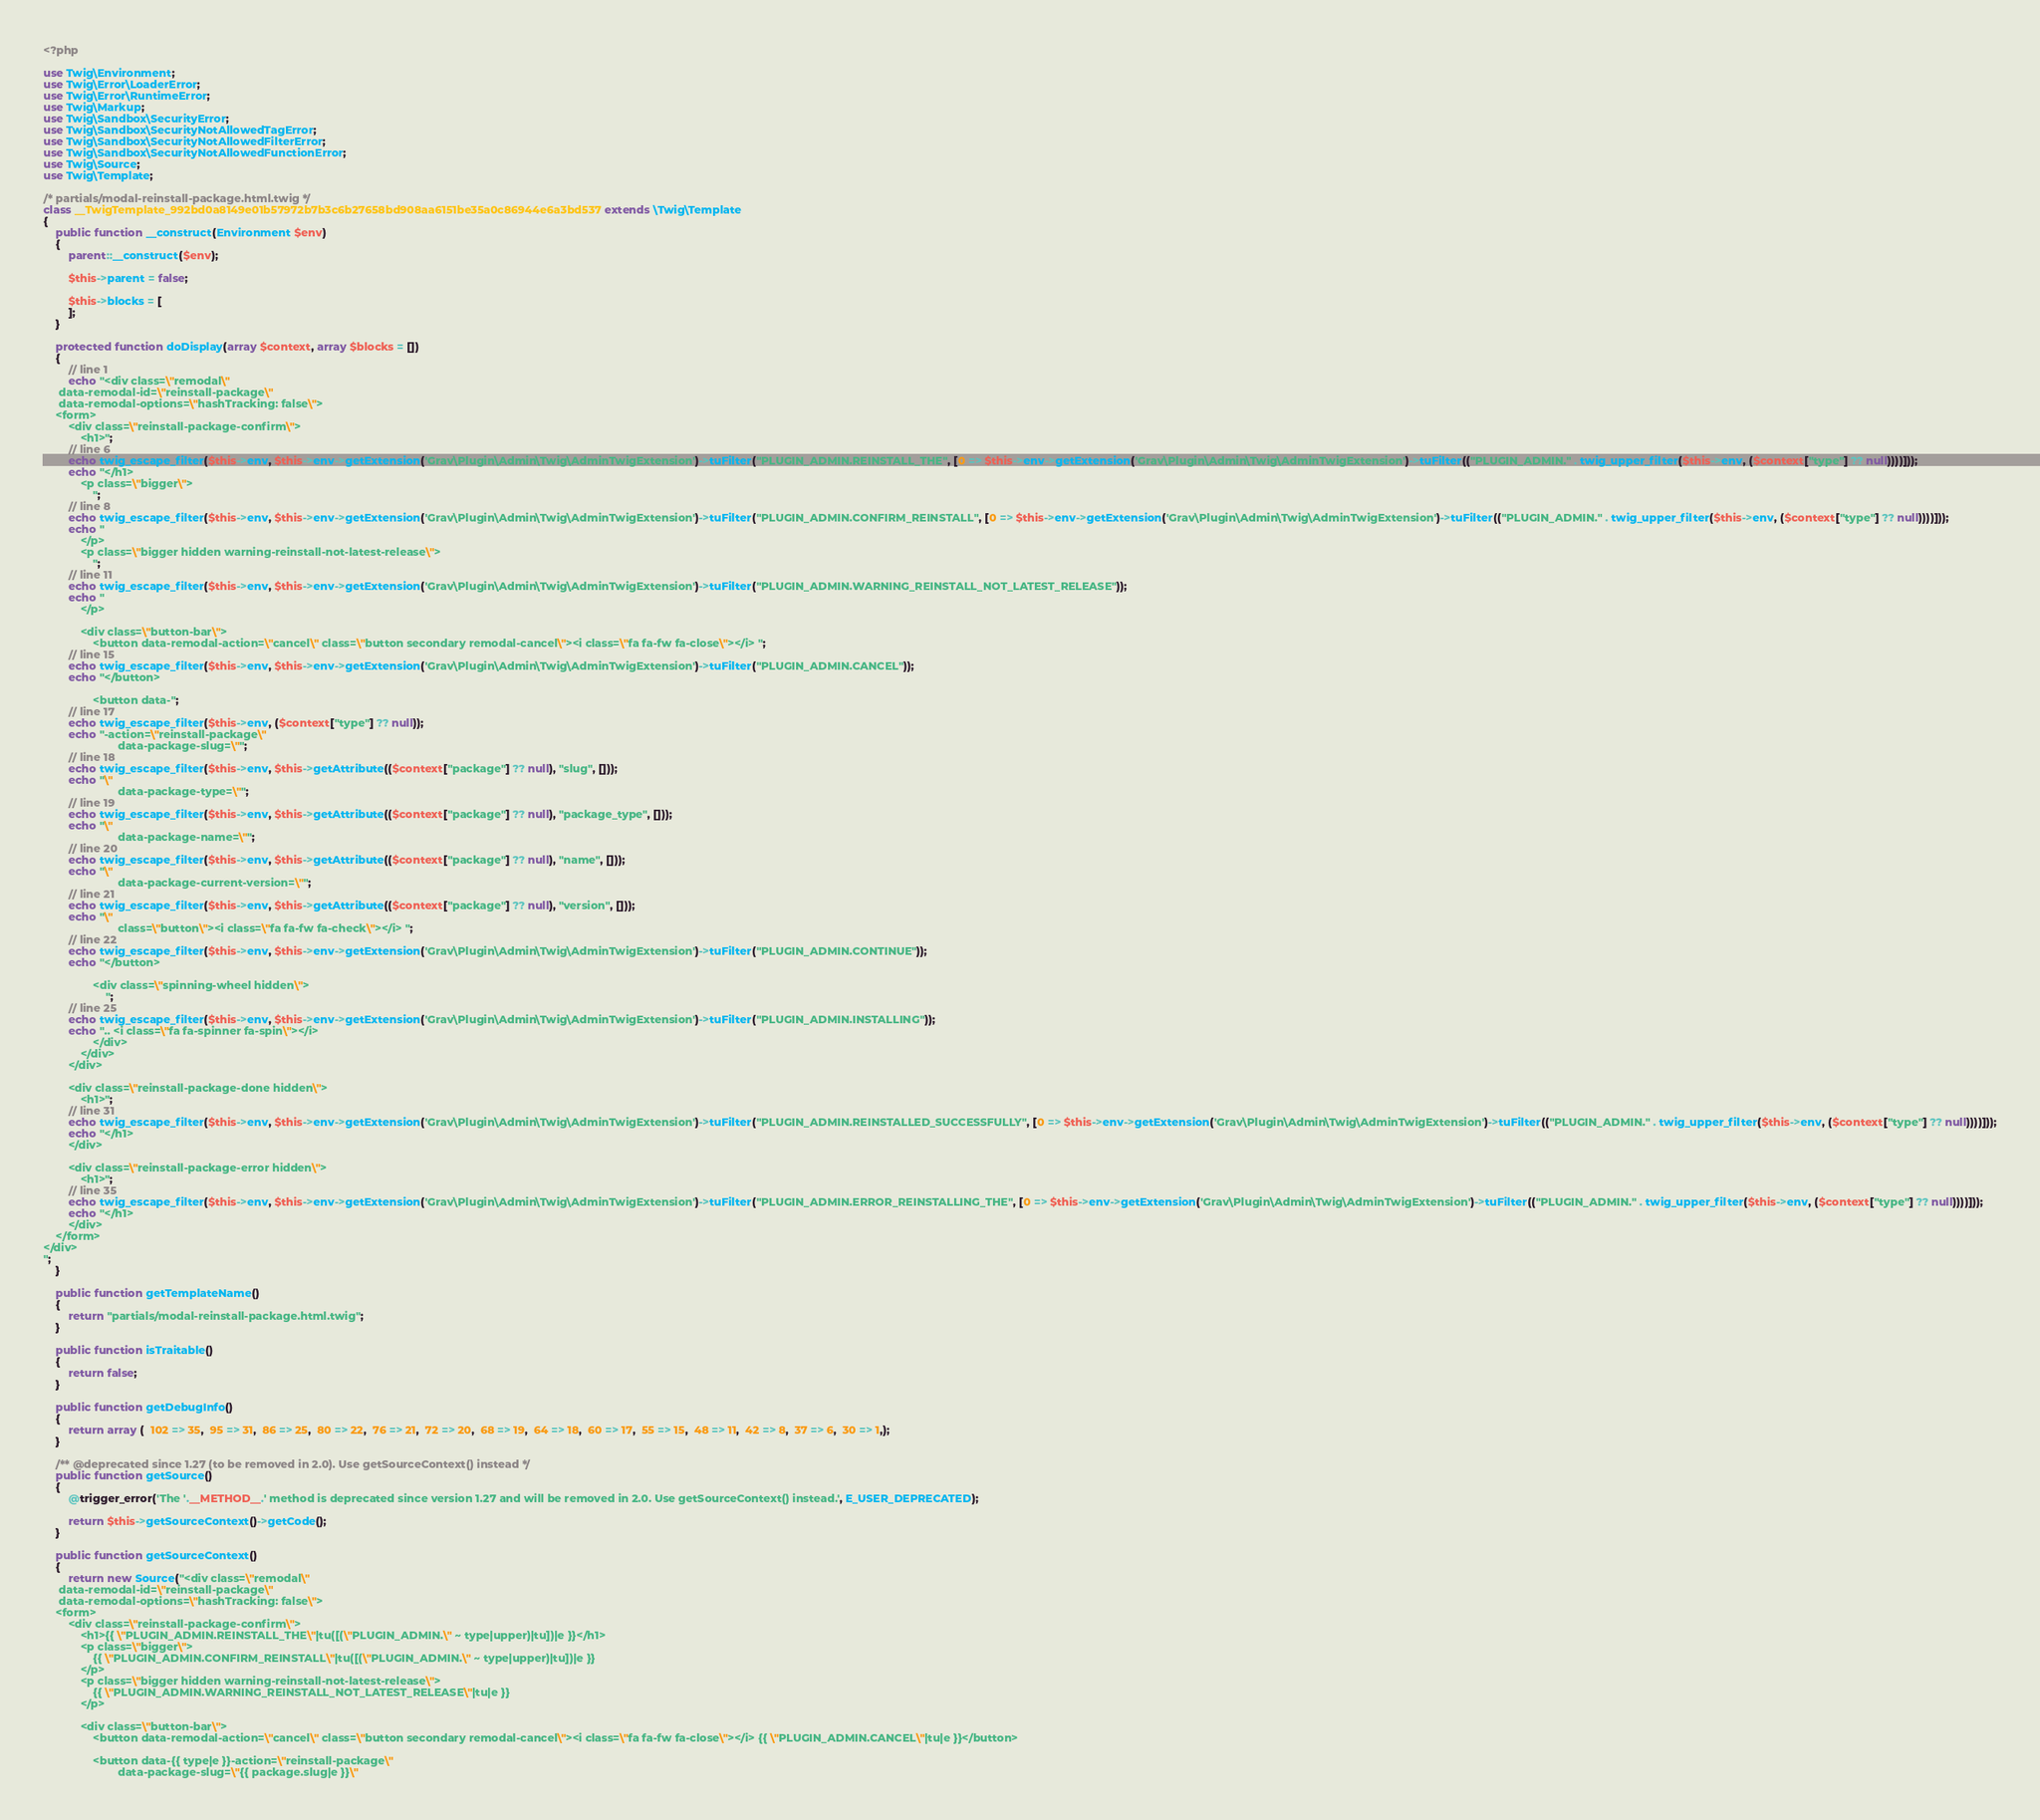<code> <loc_0><loc_0><loc_500><loc_500><_PHP_><?php

use Twig\Environment;
use Twig\Error\LoaderError;
use Twig\Error\RuntimeError;
use Twig\Markup;
use Twig\Sandbox\SecurityError;
use Twig\Sandbox\SecurityNotAllowedTagError;
use Twig\Sandbox\SecurityNotAllowedFilterError;
use Twig\Sandbox\SecurityNotAllowedFunctionError;
use Twig\Source;
use Twig\Template;

/* partials/modal-reinstall-package.html.twig */
class __TwigTemplate_992bd0a8149e01b57972b7b3c6b27658bd908aa6151be35a0c86944e6a3bd537 extends \Twig\Template
{
    public function __construct(Environment $env)
    {
        parent::__construct($env);

        $this->parent = false;

        $this->blocks = [
        ];
    }

    protected function doDisplay(array $context, array $blocks = [])
    {
        // line 1
        echo "<div class=\"remodal\"
     data-remodal-id=\"reinstall-package\"
     data-remodal-options=\"hashTracking: false\">
    <form>
        <div class=\"reinstall-package-confirm\">
            <h1>";
        // line 6
        echo twig_escape_filter($this->env, $this->env->getExtension('Grav\Plugin\Admin\Twig\AdminTwigExtension')->tuFilter("PLUGIN_ADMIN.REINSTALL_THE", [0 => $this->env->getExtension('Grav\Plugin\Admin\Twig\AdminTwigExtension')->tuFilter(("PLUGIN_ADMIN." . twig_upper_filter($this->env, ($context["type"] ?? null))))]));
        echo "</h1>
            <p class=\"bigger\">
                ";
        // line 8
        echo twig_escape_filter($this->env, $this->env->getExtension('Grav\Plugin\Admin\Twig\AdminTwigExtension')->tuFilter("PLUGIN_ADMIN.CONFIRM_REINSTALL", [0 => $this->env->getExtension('Grav\Plugin\Admin\Twig\AdminTwigExtension')->tuFilter(("PLUGIN_ADMIN." . twig_upper_filter($this->env, ($context["type"] ?? null))))]));
        echo "
            </p>
            <p class=\"bigger hidden warning-reinstall-not-latest-release\">
                ";
        // line 11
        echo twig_escape_filter($this->env, $this->env->getExtension('Grav\Plugin\Admin\Twig\AdminTwigExtension')->tuFilter("PLUGIN_ADMIN.WARNING_REINSTALL_NOT_LATEST_RELEASE"));
        echo "
            </p>

            <div class=\"button-bar\">
                <button data-remodal-action=\"cancel\" class=\"button secondary remodal-cancel\"><i class=\"fa fa-fw fa-close\"></i> ";
        // line 15
        echo twig_escape_filter($this->env, $this->env->getExtension('Grav\Plugin\Admin\Twig\AdminTwigExtension')->tuFilter("PLUGIN_ADMIN.CANCEL"));
        echo "</button>

                <button data-";
        // line 17
        echo twig_escape_filter($this->env, ($context["type"] ?? null));
        echo "-action=\"reinstall-package\"
                        data-package-slug=\"";
        // line 18
        echo twig_escape_filter($this->env, $this->getAttribute(($context["package"] ?? null), "slug", []));
        echo "\"
                        data-package-type=\"";
        // line 19
        echo twig_escape_filter($this->env, $this->getAttribute(($context["package"] ?? null), "package_type", []));
        echo "\"
                        data-package-name=\"";
        // line 20
        echo twig_escape_filter($this->env, $this->getAttribute(($context["package"] ?? null), "name", []));
        echo "\"
                        data-package-current-version=\"";
        // line 21
        echo twig_escape_filter($this->env, $this->getAttribute(($context["package"] ?? null), "version", []));
        echo "\"
                        class=\"button\"><i class=\"fa fa-fw fa-check\"></i> ";
        // line 22
        echo twig_escape_filter($this->env, $this->env->getExtension('Grav\Plugin\Admin\Twig\AdminTwigExtension')->tuFilter("PLUGIN_ADMIN.CONTINUE"));
        echo "</button>

                <div class=\"spinning-wheel hidden\">
                    ";
        // line 25
        echo twig_escape_filter($this->env, $this->env->getExtension('Grav\Plugin\Admin\Twig\AdminTwigExtension')->tuFilter("PLUGIN_ADMIN.INSTALLING"));
        echo ".. <i class=\"fa fa-spinner fa-spin\"></i>
                </div>
            </div>
        </div>

        <div class=\"reinstall-package-done hidden\">
            <h1>";
        // line 31
        echo twig_escape_filter($this->env, $this->env->getExtension('Grav\Plugin\Admin\Twig\AdminTwigExtension')->tuFilter("PLUGIN_ADMIN.REINSTALLED_SUCCESSFULLY", [0 => $this->env->getExtension('Grav\Plugin\Admin\Twig\AdminTwigExtension')->tuFilter(("PLUGIN_ADMIN." . twig_upper_filter($this->env, ($context["type"] ?? null))))]));
        echo "</h1>
        </div>

        <div class=\"reinstall-package-error hidden\">
            <h1>";
        // line 35
        echo twig_escape_filter($this->env, $this->env->getExtension('Grav\Plugin\Admin\Twig\AdminTwigExtension')->tuFilter("PLUGIN_ADMIN.ERROR_REINSTALLING_THE", [0 => $this->env->getExtension('Grav\Plugin\Admin\Twig\AdminTwigExtension')->tuFilter(("PLUGIN_ADMIN." . twig_upper_filter($this->env, ($context["type"] ?? null))))]));
        echo "</h1>
        </div>
    </form>
</div>
";
    }

    public function getTemplateName()
    {
        return "partials/modal-reinstall-package.html.twig";
    }

    public function isTraitable()
    {
        return false;
    }

    public function getDebugInfo()
    {
        return array (  102 => 35,  95 => 31,  86 => 25,  80 => 22,  76 => 21,  72 => 20,  68 => 19,  64 => 18,  60 => 17,  55 => 15,  48 => 11,  42 => 8,  37 => 6,  30 => 1,);
    }

    /** @deprecated since 1.27 (to be removed in 2.0). Use getSourceContext() instead */
    public function getSource()
    {
        @trigger_error('The '.__METHOD__.' method is deprecated since version 1.27 and will be removed in 2.0. Use getSourceContext() instead.', E_USER_DEPRECATED);

        return $this->getSourceContext()->getCode();
    }

    public function getSourceContext()
    {
        return new Source("<div class=\"remodal\"
     data-remodal-id=\"reinstall-package\"
     data-remodal-options=\"hashTracking: false\">
    <form>
        <div class=\"reinstall-package-confirm\">
            <h1>{{ \"PLUGIN_ADMIN.REINSTALL_THE\"|tu([(\"PLUGIN_ADMIN.\" ~ type|upper)|tu])|e }}</h1>
            <p class=\"bigger\">
                {{ \"PLUGIN_ADMIN.CONFIRM_REINSTALL\"|tu([(\"PLUGIN_ADMIN.\" ~ type|upper)|tu])|e }}
            </p>
            <p class=\"bigger hidden warning-reinstall-not-latest-release\">
                {{ \"PLUGIN_ADMIN.WARNING_REINSTALL_NOT_LATEST_RELEASE\"|tu|e }}
            </p>

            <div class=\"button-bar\">
                <button data-remodal-action=\"cancel\" class=\"button secondary remodal-cancel\"><i class=\"fa fa-fw fa-close\"></i> {{ \"PLUGIN_ADMIN.CANCEL\"|tu|e }}</button>

                <button data-{{ type|e }}-action=\"reinstall-package\"
                        data-package-slug=\"{{ package.slug|e }}\"</code> 